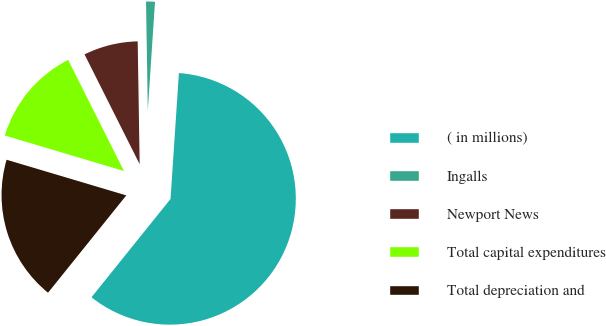<chart> <loc_0><loc_0><loc_500><loc_500><pie_chart><fcel>( in millions)<fcel>Ingalls<fcel>Newport News<fcel>Total capital expenditures<fcel>Total depreciation and<nl><fcel>59.73%<fcel>1.31%<fcel>7.15%<fcel>12.99%<fcel>18.83%<nl></chart> 